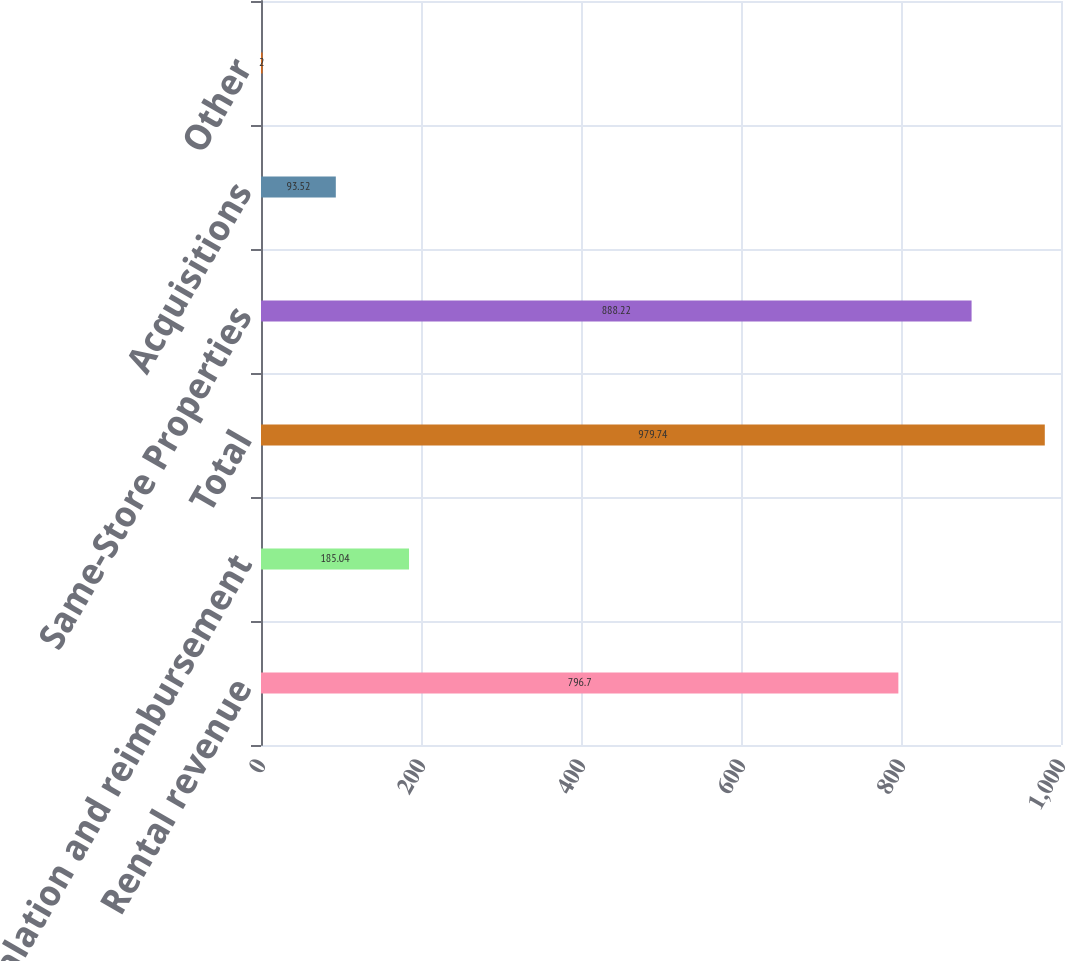Convert chart to OTSL. <chart><loc_0><loc_0><loc_500><loc_500><bar_chart><fcel>Rental revenue<fcel>Escalation and reimbursement<fcel>Total<fcel>Same-Store Properties<fcel>Acquisitions<fcel>Other<nl><fcel>796.7<fcel>185.04<fcel>979.74<fcel>888.22<fcel>93.52<fcel>2<nl></chart> 